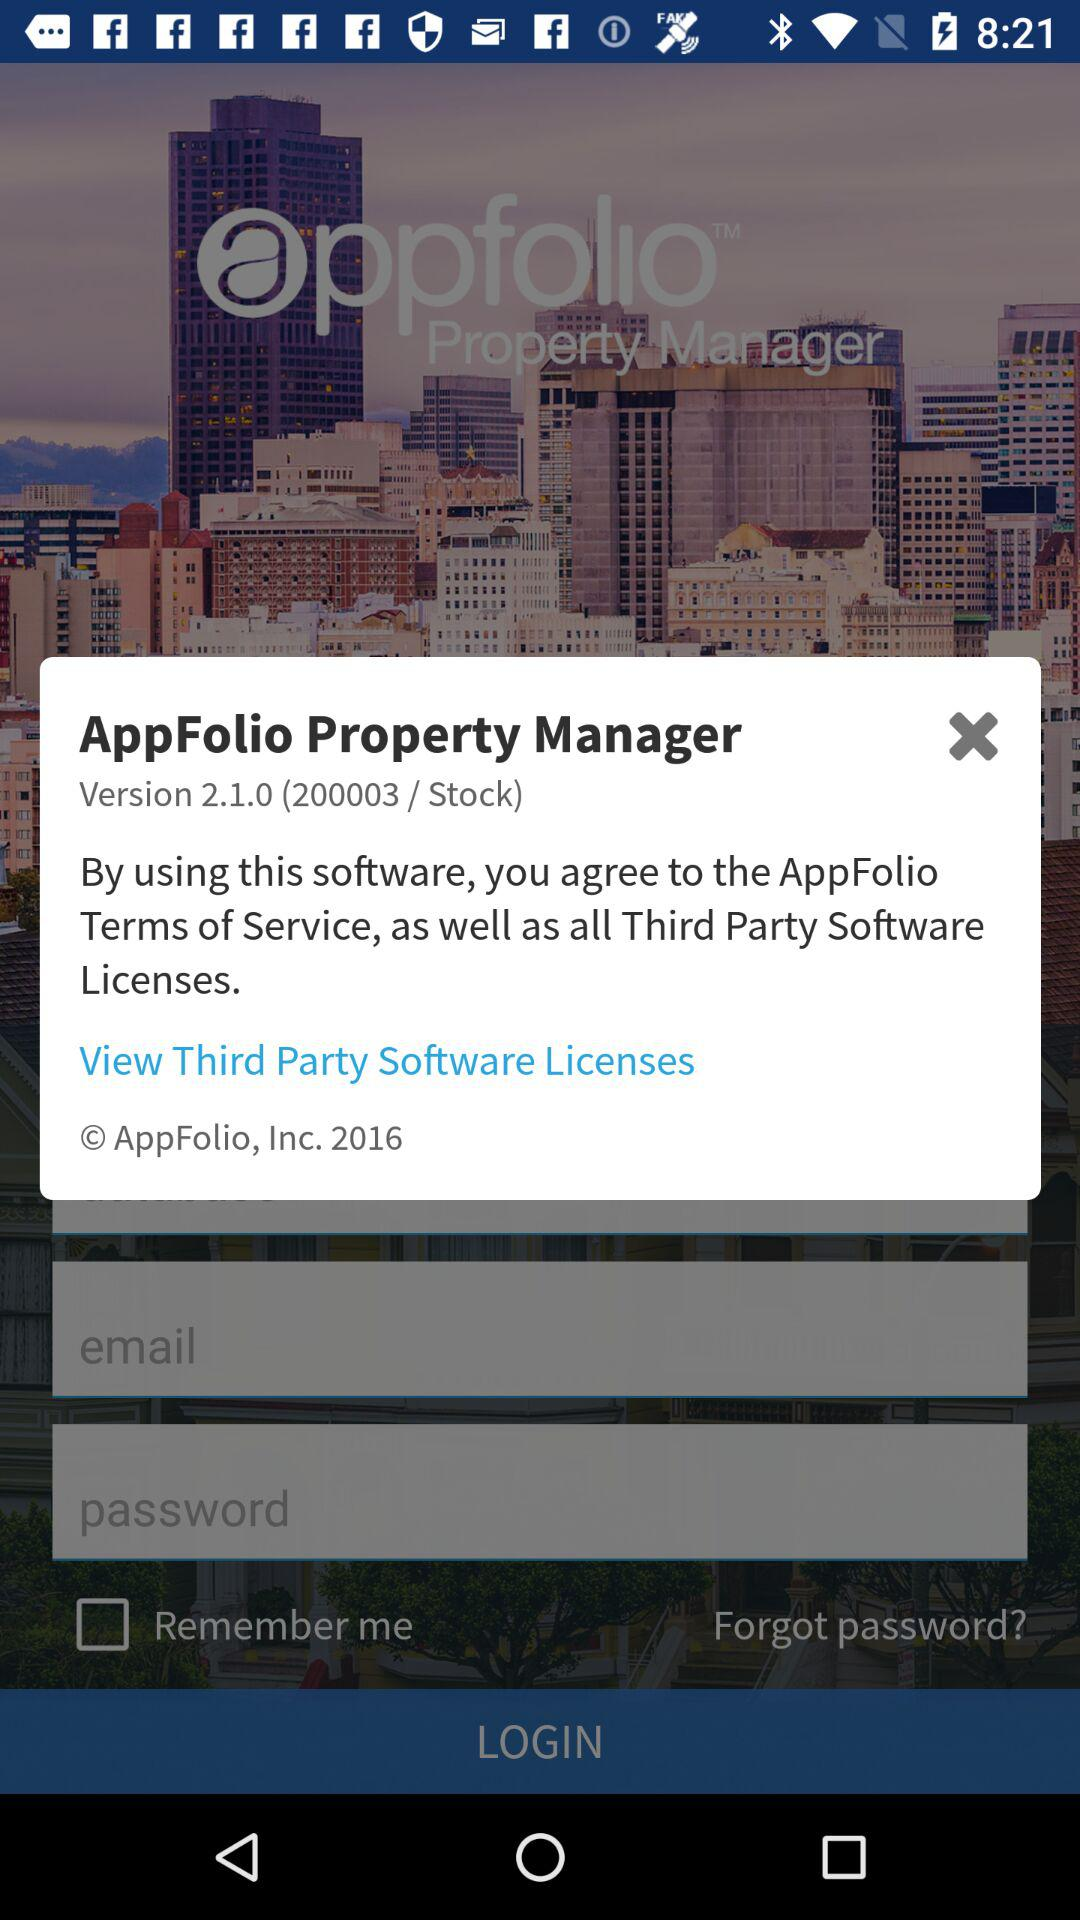What is the application name? The application name is "AppFolio Property Manager". 